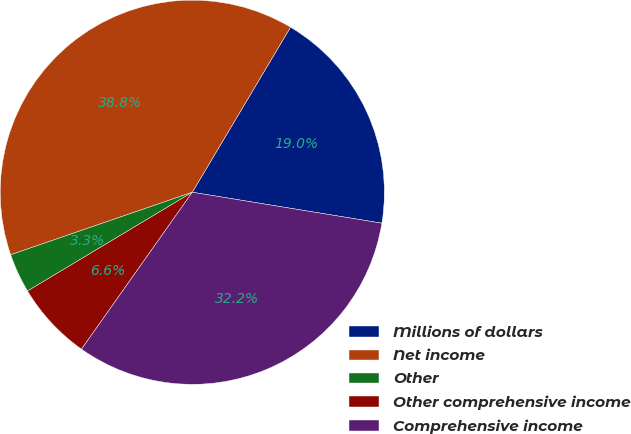<chart> <loc_0><loc_0><loc_500><loc_500><pie_chart><fcel>Millions of dollars<fcel>Net income<fcel>Other<fcel>Other comprehensive income<fcel>Comprehensive income<nl><fcel>19.03%<fcel>38.82%<fcel>3.32%<fcel>6.62%<fcel>32.21%<nl></chart> 